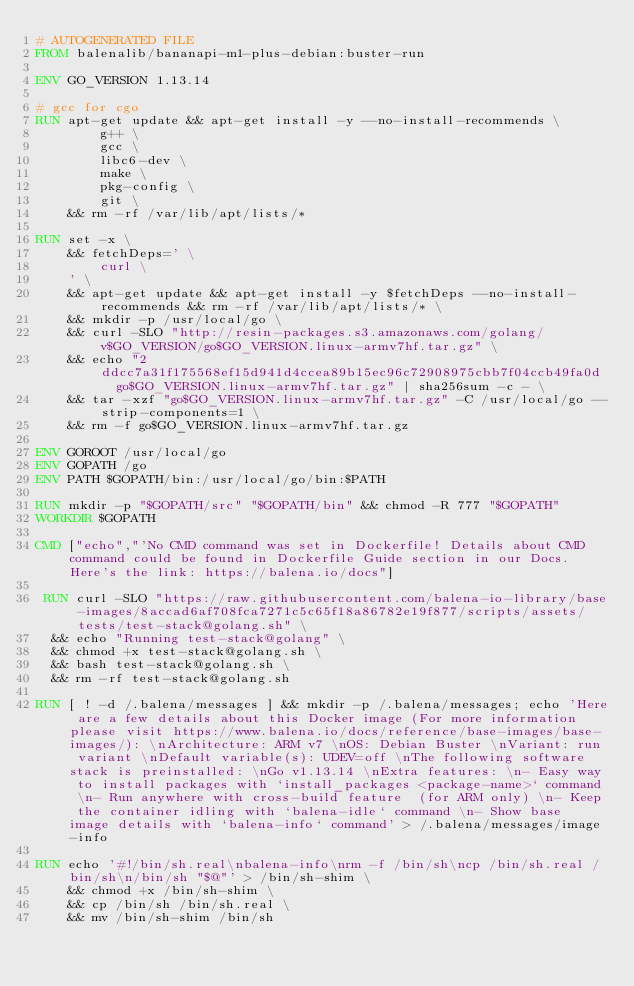<code> <loc_0><loc_0><loc_500><loc_500><_Dockerfile_># AUTOGENERATED FILE
FROM balenalib/bananapi-m1-plus-debian:buster-run

ENV GO_VERSION 1.13.14

# gcc for cgo
RUN apt-get update && apt-get install -y --no-install-recommends \
		g++ \
		gcc \
		libc6-dev \
		make \
		pkg-config \
		git \
	&& rm -rf /var/lib/apt/lists/*

RUN set -x \
	&& fetchDeps=' \
		curl \
	' \
	&& apt-get update && apt-get install -y $fetchDeps --no-install-recommends && rm -rf /var/lib/apt/lists/* \
	&& mkdir -p /usr/local/go \
	&& curl -SLO "http://resin-packages.s3.amazonaws.com/golang/v$GO_VERSION/go$GO_VERSION.linux-armv7hf.tar.gz" \
	&& echo "2ddcc7a31f175568ef15d941d4ccea89b15ec96c72908975cbb7f04ccb49fa0d  go$GO_VERSION.linux-armv7hf.tar.gz" | sha256sum -c - \
	&& tar -xzf "go$GO_VERSION.linux-armv7hf.tar.gz" -C /usr/local/go --strip-components=1 \
	&& rm -f go$GO_VERSION.linux-armv7hf.tar.gz

ENV GOROOT /usr/local/go
ENV GOPATH /go
ENV PATH $GOPATH/bin:/usr/local/go/bin:$PATH

RUN mkdir -p "$GOPATH/src" "$GOPATH/bin" && chmod -R 777 "$GOPATH"
WORKDIR $GOPATH

CMD ["echo","'No CMD command was set in Dockerfile! Details about CMD command could be found in Dockerfile Guide section in our Docs. Here's the link: https://balena.io/docs"]

 RUN curl -SLO "https://raw.githubusercontent.com/balena-io-library/base-images/8accad6af708fca7271c5c65f18a86782e19f877/scripts/assets/tests/test-stack@golang.sh" \
  && echo "Running test-stack@golang" \
  && chmod +x test-stack@golang.sh \
  && bash test-stack@golang.sh \
  && rm -rf test-stack@golang.sh 

RUN [ ! -d /.balena/messages ] && mkdir -p /.balena/messages; echo 'Here are a few details about this Docker image (For more information please visit https://www.balena.io/docs/reference/base-images/base-images/): \nArchitecture: ARM v7 \nOS: Debian Buster \nVariant: run variant \nDefault variable(s): UDEV=off \nThe following software stack is preinstalled: \nGo v1.13.14 \nExtra features: \n- Easy way to install packages with `install_packages <package-name>` command \n- Run anywhere with cross-build feature  (for ARM only) \n- Keep the container idling with `balena-idle` command \n- Show base image details with `balena-info` command' > /.balena/messages/image-info

RUN echo '#!/bin/sh.real\nbalena-info\nrm -f /bin/sh\ncp /bin/sh.real /bin/sh\n/bin/sh "$@"' > /bin/sh-shim \
	&& chmod +x /bin/sh-shim \
	&& cp /bin/sh /bin/sh.real \
	&& mv /bin/sh-shim /bin/sh</code> 